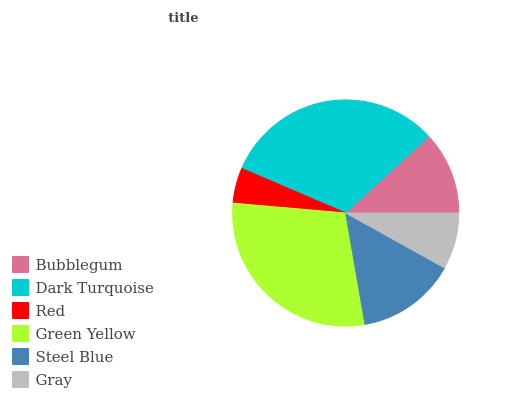Is Red the minimum?
Answer yes or no. Yes. Is Dark Turquoise the maximum?
Answer yes or no. Yes. Is Dark Turquoise the minimum?
Answer yes or no. No. Is Red the maximum?
Answer yes or no. No. Is Dark Turquoise greater than Red?
Answer yes or no. Yes. Is Red less than Dark Turquoise?
Answer yes or no. Yes. Is Red greater than Dark Turquoise?
Answer yes or no. No. Is Dark Turquoise less than Red?
Answer yes or no. No. Is Steel Blue the high median?
Answer yes or no. Yes. Is Bubblegum the low median?
Answer yes or no. Yes. Is Green Yellow the high median?
Answer yes or no. No. Is Green Yellow the low median?
Answer yes or no. No. 